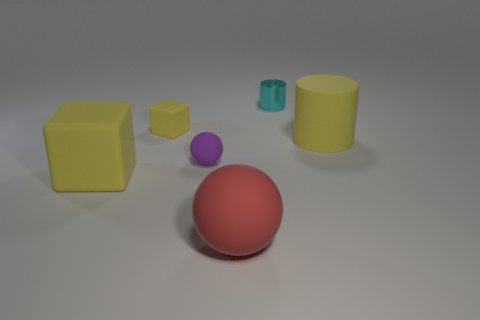Do the small matte block and the large cube have the same color?
Offer a very short reply. Yes. Does the rubber cube in front of the purple rubber ball have the same size as the yellow rubber thing on the right side of the small cyan metallic cylinder?
Provide a succinct answer. Yes. What is the shape of the large red matte thing?
Your response must be concise. Sphere. What is the size of the other matte cube that is the same color as the big matte block?
Keep it short and to the point. Small. There is a cylinder that is the same material as the tiny purple sphere; what color is it?
Your answer should be very brief. Yellow. Does the small cyan object have the same material as the big yellow object left of the big cylinder?
Ensure brevity in your answer.  No. The small shiny object is what color?
Keep it short and to the point. Cyan. What is the size of the other yellow cube that is made of the same material as the big cube?
Provide a succinct answer. Small. What number of small objects are on the left side of the sphere behind the matte cube that is left of the tiny yellow matte cube?
Provide a succinct answer. 1. Do the big cylinder and the block to the left of the small yellow rubber thing have the same color?
Offer a very short reply. Yes. 